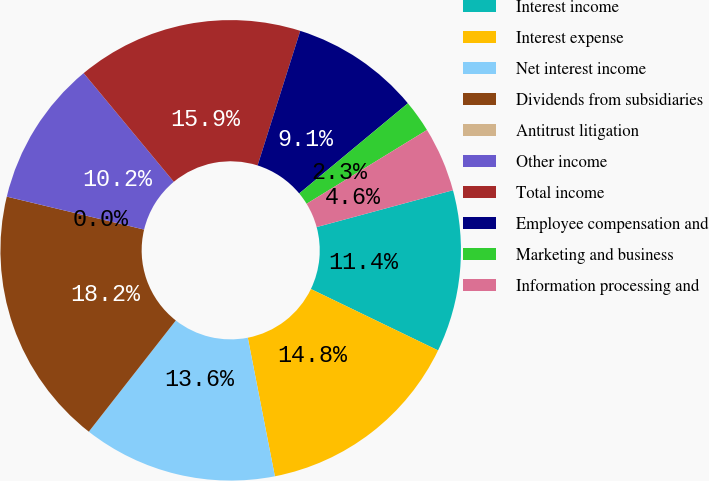<chart> <loc_0><loc_0><loc_500><loc_500><pie_chart><fcel>Interest income<fcel>Interest expense<fcel>Net interest income<fcel>Dividends from subsidiaries<fcel>Antitrust litigation<fcel>Other income<fcel>Total income<fcel>Employee compensation and<fcel>Marketing and business<fcel>Information processing and<nl><fcel>11.36%<fcel>14.77%<fcel>13.64%<fcel>18.18%<fcel>0.0%<fcel>10.23%<fcel>15.91%<fcel>9.09%<fcel>2.27%<fcel>4.55%<nl></chart> 